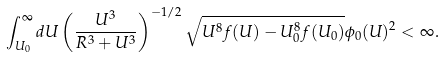<formula> <loc_0><loc_0><loc_500><loc_500>\int _ { U _ { 0 } } ^ { \infty } d U \left ( \frac { U ^ { 3 } } { R ^ { 3 } + U ^ { 3 } } \right ) ^ { - 1 / 2 } \sqrt { U ^ { 8 } f ( U ) - U _ { 0 } ^ { 8 } f ( U _ { 0 } ) } \phi _ { 0 } ( U ) ^ { 2 } < \infty .</formula> 